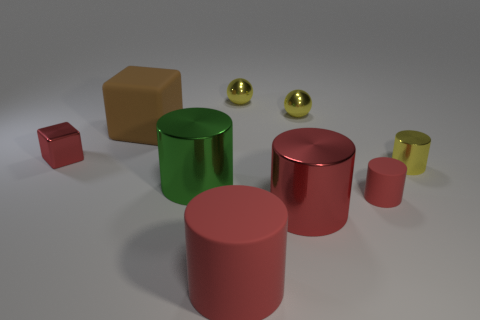Subtract all green blocks. How many red cylinders are left? 3 Subtract all green cylinders. How many cylinders are left? 4 Subtract all large red metal cylinders. How many cylinders are left? 4 Subtract all blue cylinders. Subtract all gray balls. How many cylinders are left? 5 Add 1 big red cylinders. How many objects exist? 10 Subtract all spheres. How many objects are left? 7 Subtract all blue cylinders. Subtract all big green cylinders. How many objects are left? 8 Add 2 big brown objects. How many big brown objects are left? 3 Add 9 blue shiny objects. How many blue shiny objects exist? 9 Subtract 1 red blocks. How many objects are left? 8 